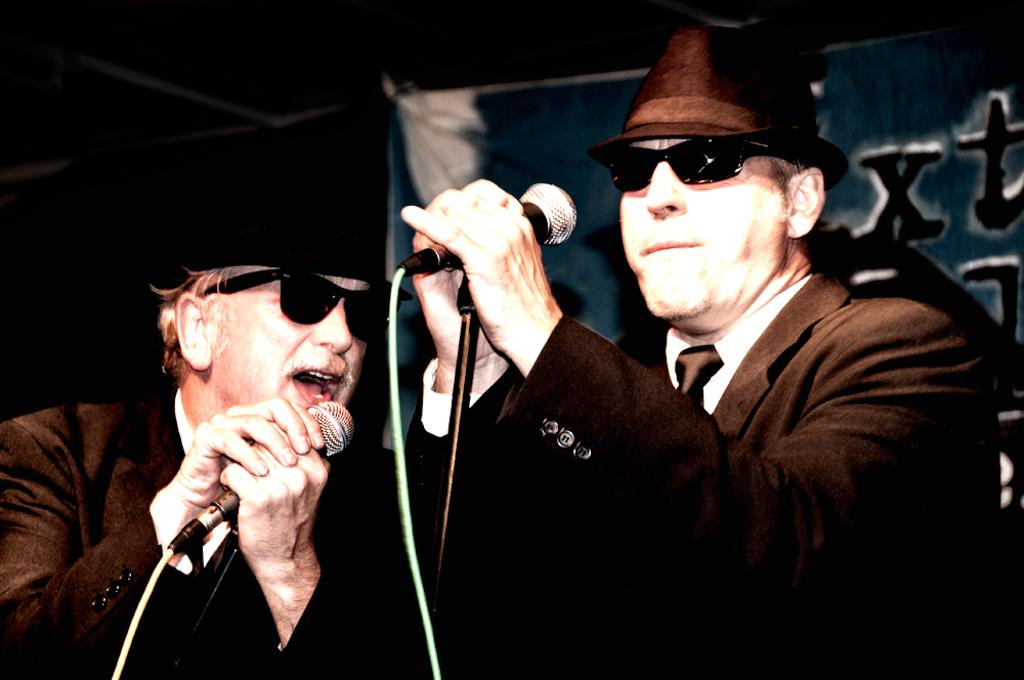How many people are in the image? There are two men in the image. What are the men holding in the image? The men are holding microphones. What is one of the men doing in the image? One of the men is singing. What type of protective eyewear are the men wearing? Both men are wearing goggles. What can be seen in the background of the image? There is a banner in the background of the image. What type of kettle is being used by the governor in the image? There is no governor or kettle present in the image. How many clovers are visible on the banner in the image? There are no clovers visible on the banner in the image. 